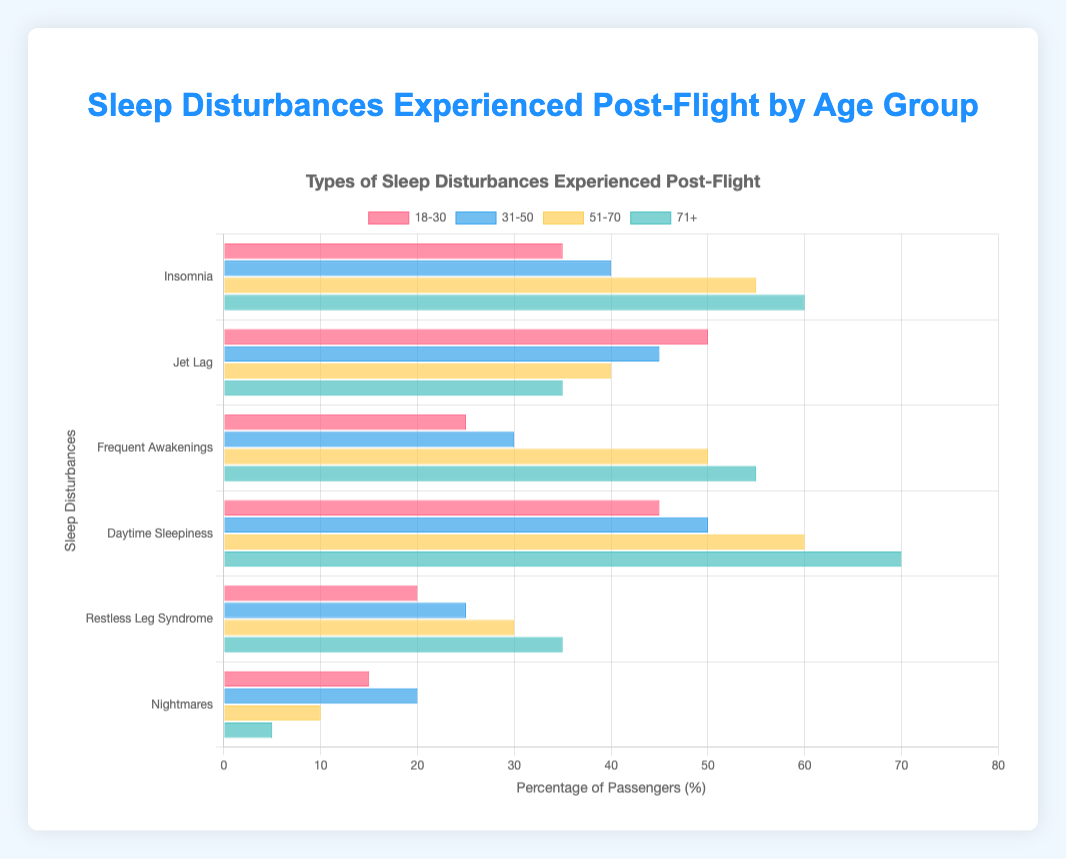What age group experiences the highest rate of insomnia post-flight? To determine the age group with the highest rate of insomnia post-flight, look for the highest value in the 'Insomnia' category across all age groups. For the "71+" age group, the rate is 60%.
Answer: 71+ Which sleep disturbance is most common for the 18-30 age group? Check the 'Sleep Disturbances' data for the 18-30 age group and find the highest value, which is in the 'Jet Lag' category with 50%.
Answer: Jet Lag Compare the prevalence of daytime sleepiness between the 31-50 and 51-70 age groups. Which has the higher rate? Look at the 'Daytime Sleepiness' values for both age groups. The 31-50 age group has 50% and the 51-70 age group has 60%. Therefore, the 51-70 age group has a higher rate.
Answer: 51-70 Which age group has the lowest occurrence of nightmares post-flight? Look at the 'Nightmares' category across all age groups and find the lowest value. The "71+" age group has the lowest occurrence at 5%.
Answer: 71+ What is the total percentage of passengers experiencing jet lag across all age groups? Sum the 'Jet Lag' percentages from all age groups: 50 (18-30) + 45 (31-50) + 40 (51-70) + 35 (71+). Thus, 50 + 45 + 40 + 35 = 170%.
Answer: 170% How many age groups experience a higher rate of frequent awakenings than nightmares in the same group? Compare the 'Frequent Awakenings' and 'Nightmares' values within each age group. All four age groups (18-30, 31-50, 51-70, 71+) have a higher rate of frequent awakenings than nightmares.
Answer: 4 What is the percentage difference in restless leg syndrome between the 51-70 and 71+ age groups? Subtract the 'Restless Leg Syndrome' percentage for the 51-70 age group (30%) from the 71+ age group (35%). Thus, 35 - 30 = 5%.
Answer: 5% Which age group has the second highest occurrence of daytime sleepiness? Rank the 'Daytime Sleepiness' values: 70% (71+), 60% (51-70), 50% (31-50), 45% (18-30). The second highest occurrence is in the 51-70 age group with 60%.
Answer: 51-70 How does the rate of frequent awakenings for the 51-70 age group compare to insomnia for the 18-30 age group? Compare the 'Frequent Awakenings' value for the 51-70 age group (50%) with the 'Insomnia' value for the 18-30 age group (35%). The 51-70 age group experiences a higher rate of frequent awakenings than the 18-30 age group does for insomnia.
Answer: 51-70 experiences more 